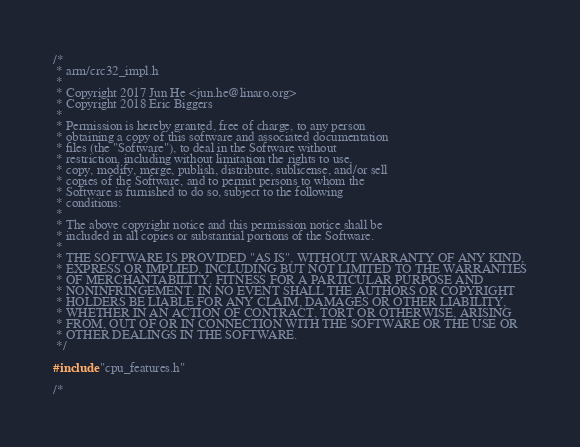<code> <loc_0><loc_0><loc_500><loc_500><_C_>/*
 * arm/crc32_impl.h
 *
 * Copyright 2017 Jun He <jun.he@linaro.org>
 * Copyright 2018 Eric Biggers
 *
 * Permission is hereby granted, free of charge, to any person
 * obtaining a copy of this software and associated documentation
 * files (the "Software"), to deal in the Software without
 * restriction, including without limitation the rights to use,
 * copy, modify, merge, publish, distribute, sublicense, and/or sell
 * copies of the Software, and to permit persons to whom the
 * Software is furnished to do so, subject to the following
 * conditions:
 *
 * The above copyright notice and this permission notice shall be
 * included in all copies or substantial portions of the Software.
 *
 * THE SOFTWARE IS PROVIDED "AS IS", WITHOUT WARRANTY OF ANY KIND,
 * EXPRESS OR IMPLIED, INCLUDING BUT NOT LIMITED TO THE WARRANTIES
 * OF MERCHANTABILITY, FITNESS FOR A PARTICULAR PURPOSE AND
 * NONINFRINGEMENT. IN NO EVENT SHALL THE AUTHORS OR COPYRIGHT
 * HOLDERS BE LIABLE FOR ANY CLAIM, DAMAGES OR OTHER LIABILITY,
 * WHETHER IN AN ACTION OF CONTRACT, TORT OR OTHERWISE, ARISING
 * FROM, OUT OF OR IN CONNECTION WITH THE SOFTWARE OR THE USE OR
 * OTHER DEALINGS IN THE SOFTWARE.
 */

#include "cpu_features.h"

/*</code> 